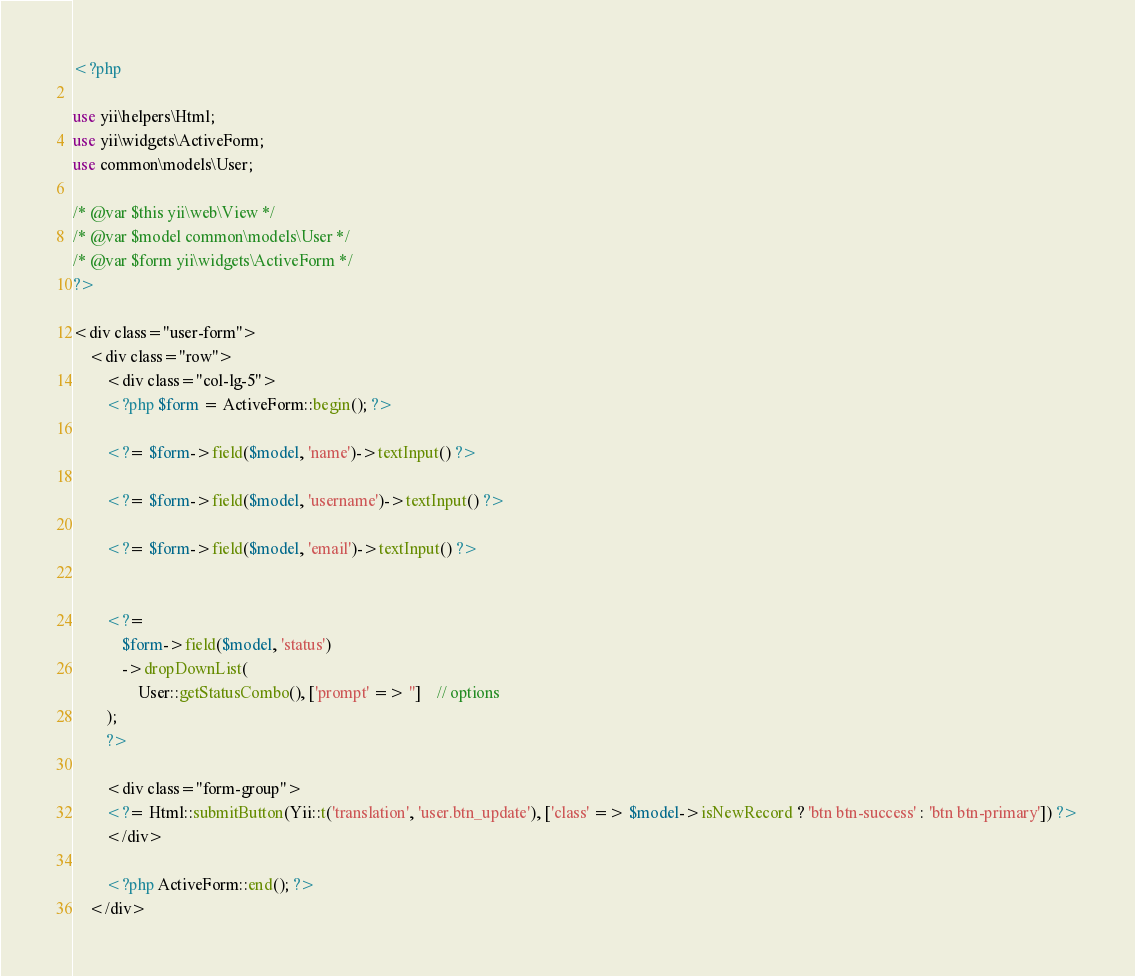<code> <loc_0><loc_0><loc_500><loc_500><_PHP_><?php

use yii\helpers\Html;
use yii\widgets\ActiveForm;
use common\models\User;

/* @var $this yii\web\View */
/* @var $model common\models\User */
/* @var $form yii\widgets\ActiveForm */
?>

<div class="user-form">
    <div class="row">
        <div class="col-lg-5">
	    <?php $form = ActiveForm::begin(); ?>

	    <?= $form->field($model, 'name')->textInput() ?>

	    <?= $form->field($model, 'username')->textInput() ?>

	    <?= $form->field($model, 'email')->textInput() ?>


	    <?=
		    $form->field($model, 'status')
		    ->dropDownList(
			    User::getStatusCombo(), ['prompt' => '']    // options
	    );
	    ?>

	    <div class="form-group">
		<?= Html::submitButton(Yii::t('translation', 'user.btn_update'), ['class' => $model->isNewRecord ? 'btn btn-success' : 'btn btn-primary']) ?>
	    </div>

	    <?php ActiveForm::end(); ?>
	</div></code> 